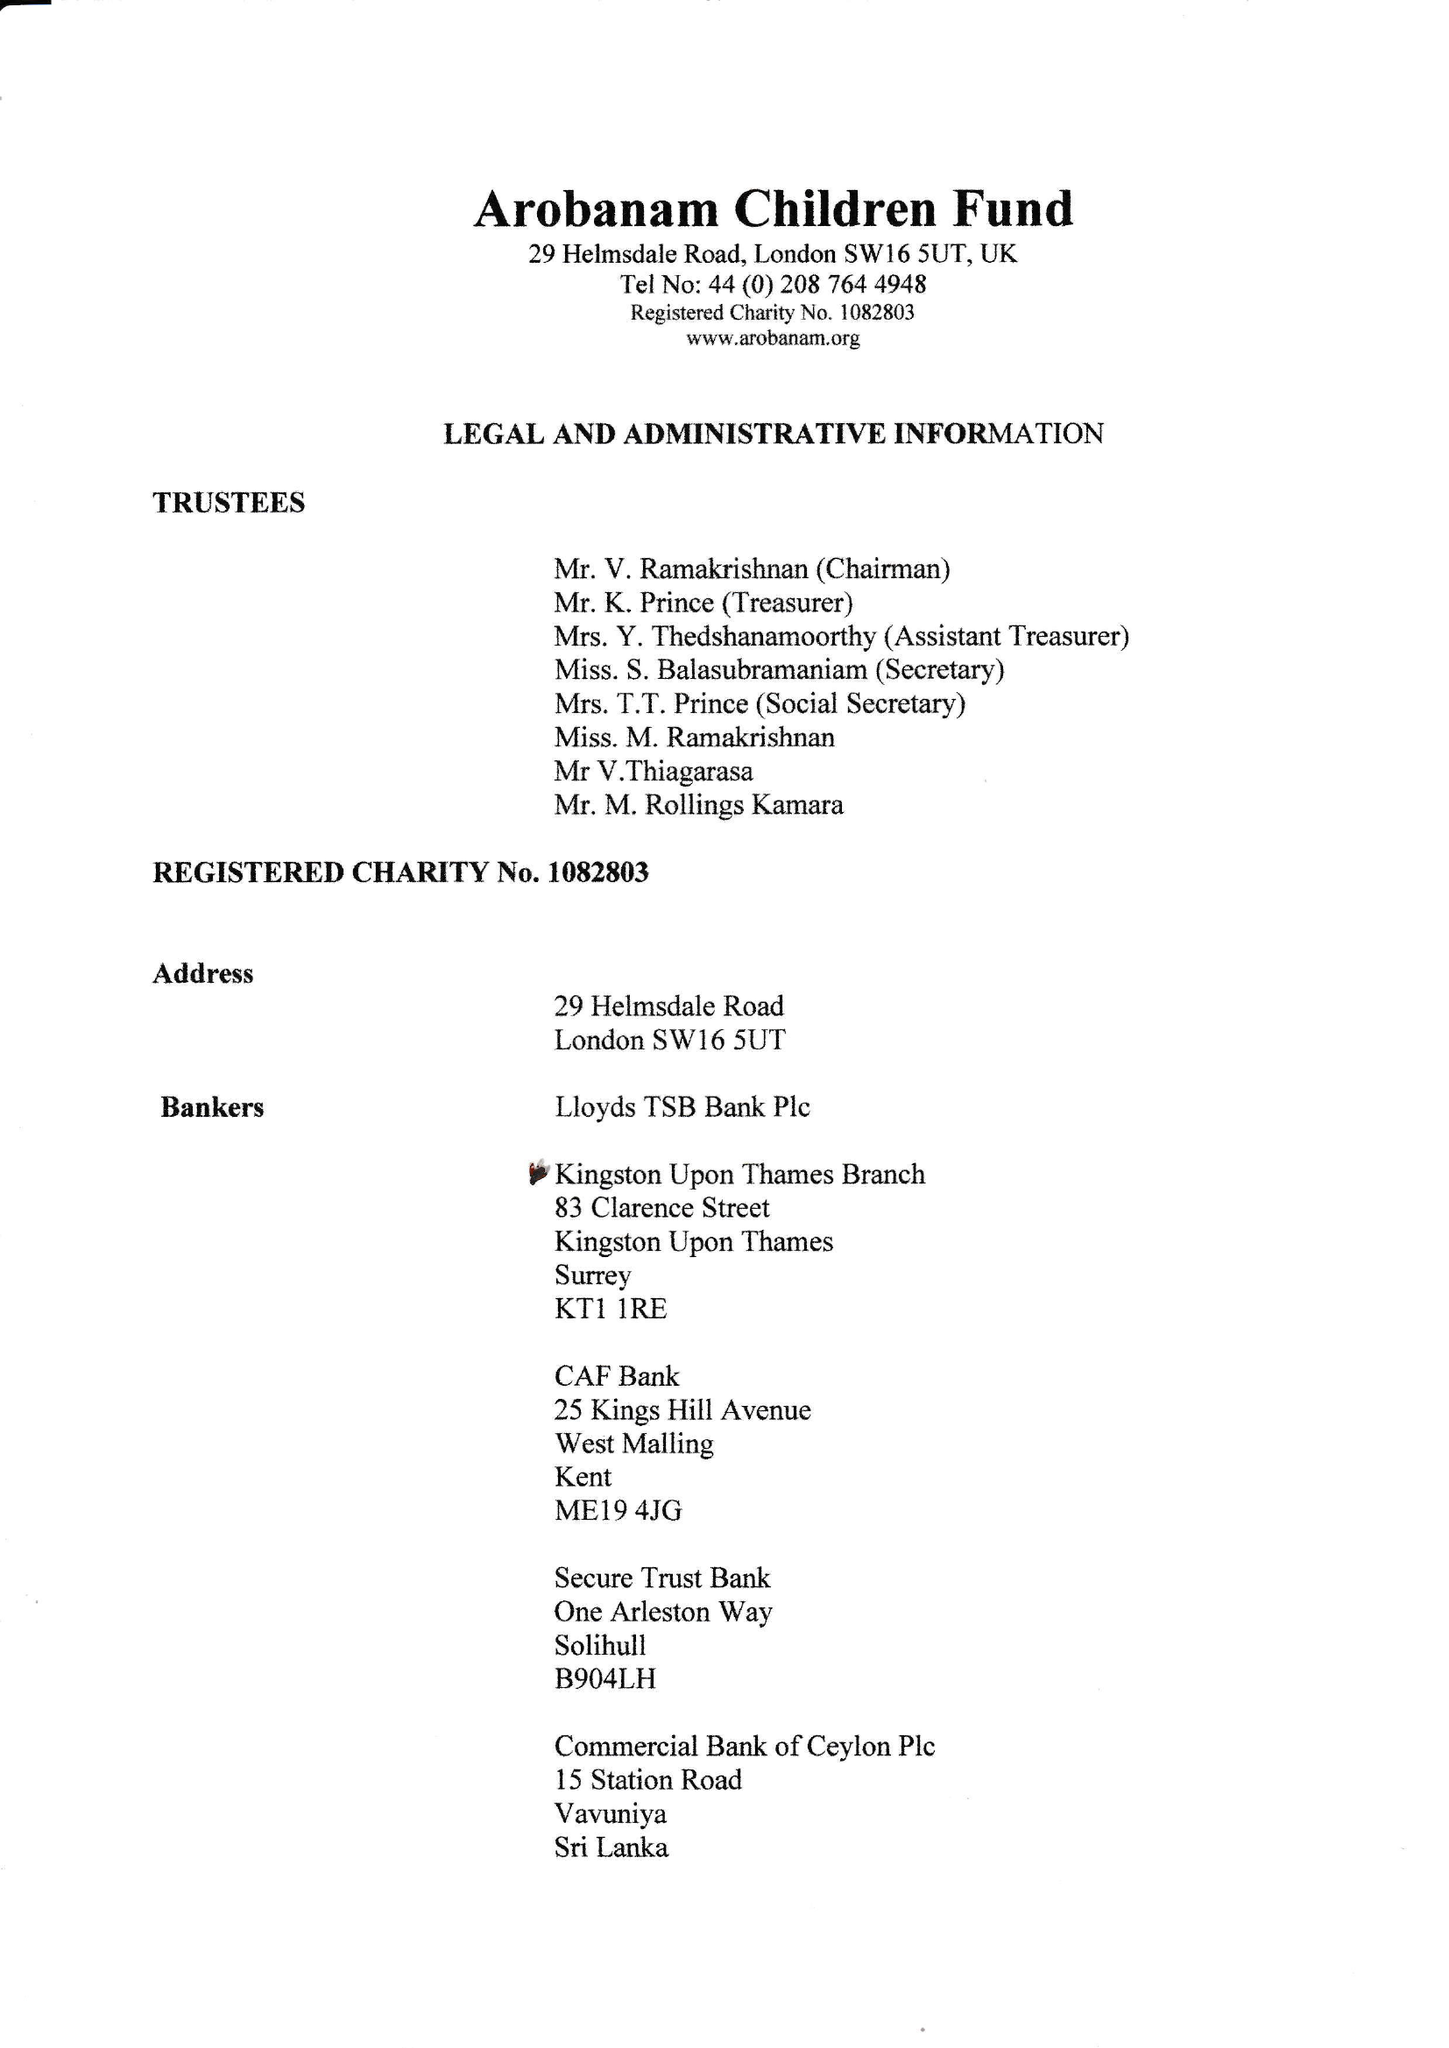What is the value for the income_annually_in_british_pounds?
Answer the question using a single word or phrase. 131883.00 